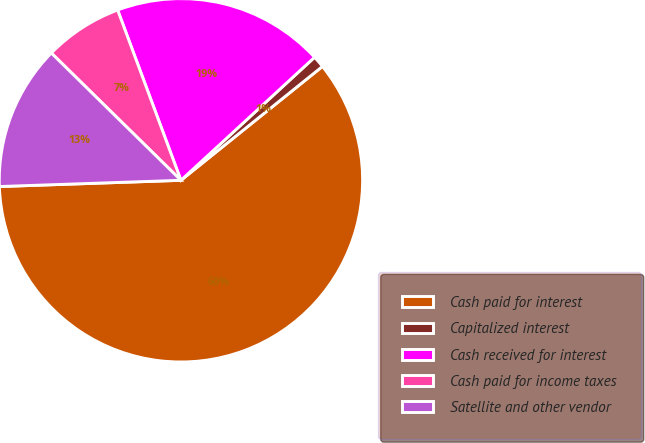Convert chart to OTSL. <chart><loc_0><loc_0><loc_500><loc_500><pie_chart><fcel>Cash paid for interest<fcel>Capitalized interest<fcel>Cash received for interest<fcel>Cash paid for income taxes<fcel>Satellite and other vendor<nl><fcel>60.24%<fcel>1.06%<fcel>18.82%<fcel>6.98%<fcel>12.9%<nl></chart> 